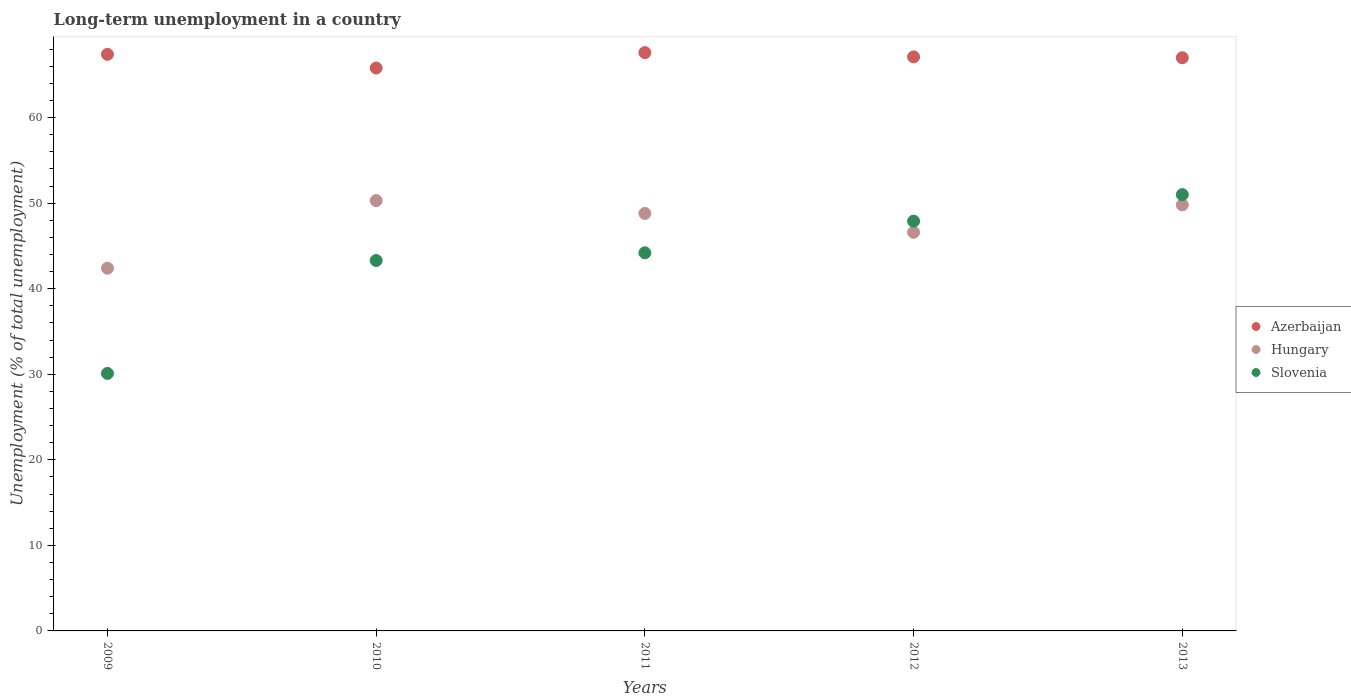How many different coloured dotlines are there?
Offer a very short reply. 3. Is the number of dotlines equal to the number of legend labels?
Give a very brief answer. Yes. What is the percentage of long-term unemployed population in Azerbaijan in 2010?
Your answer should be compact. 65.8. Across all years, what is the maximum percentage of long-term unemployed population in Slovenia?
Provide a succinct answer. 51. Across all years, what is the minimum percentage of long-term unemployed population in Hungary?
Your answer should be very brief. 42.4. In which year was the percentage of long-term unemployed population in Slovenia maximum?
Make the answer very short. 2013. What is the total percentage of long-term unemployed population in Hungary in the graph?
Your answer should be compact. 237.9. What is the difference between the percentage of long-term unemployed population in Hungary in 2009 and that in 2013?
Keep it short and to the point. -7.4. What is the difference between the percentage of long-term unemployed population in Hungary in 2011 and the percentage of long-term unemployed population in Slovenia in 2012?
Make the answer very short. 0.9. What is the average percentage of long-term unemployed population in Slovenia per year?
Give a very brief answer. 43.3. In the year 2009, what is the difference between the percentage of long-term unemployed population in Hungary and percentage of long-term unemployed population in Slovenia?
Give a very brief answer. 12.3. What is the ratio of the percentage of long-term unemployed population in Hungary in 2009 to that in 2011?
Provide a succinct answer. 0.87. What is the difference between the highest and the second highest percentage of long-term unemployed population in Azerbaijan?
Keep it short and to the point. 0.2. What is the difference between the highest and the lowest percentage of long-term unemployed population in Hungary?
Provide a succinct answer. 7.9. Is the sum of the percentage of long-term unemployed population in Slovenia in 2011 and 2013 greater than the maximum percentage of long-term unemployed population in Azerbaijan across all years?
Your answer should be very brief. Yes. Is it the case that in every year, the sum of the percentage of long-term unemployed population in Slovenia and percentage of long-term unemployed population in Hungary  is greater than the percentage of long-term unemployed population in Azerbaijan?
Keep it short and to the point. Yes. Is the percentage of long-term unemployed population in Azerbaijan strictly less than the percentage of long-term unemployed population in Hungary over the years?
Ensure brevity in your answer.  No. How many years are there in the graph?
Make the answer very short. 5. What is the difference between two consecutive major ticks on the Y-axis?
Ensure brevity in your answer.  10. Does the graph contain grids?
Provide a short and direct response. No. Where does the legend appear in the graph?
Ensure brevity in your answer.  Center right. How many legend labels are there?
Provide a short and direct response. 3. What is the title of the graph?
Make the answer very short. Long-term unemployment in a country. Does "Caribbean small states" appear as one of the legend labels in the graph?
Offer a terse response. No. What is the label or title of the X-axis?
Provide a succinct answer. Years. What is the label or title of the Y-axis?
Keep it short and to the point. Unemployment (% of total unemployment). What is the Unemployment (% of total unemployment) of Azerbaijan in 2009?
Give a very brief answer. 67.4. What is the Unemployment (% of total unemployment) in Hungary in 2009?
Your response must be concise. 42.4. What is the Unemployment (% of total unemployment) of Slovenia in 2009?
Provide a succinct answer. 30.1. What is the Unemployment (% of total unemployment) of Azerbaijan in 2010?
Ensure brevity in your answer.  65.8. What is the Unemployment (% of total unemployment) in Hungary in 2010?
Ensure brevity in your answer.  50.3. What is the Unemployment (% of total unemployment) in Slovenia in 2010?
Ensure brevity in your answer.  43.3. What is the Unemployment (% of total unemployment) in Azerbaijan in 2011?
Offer a very short reply. 67.6. What is the Unemployment (% of total unemployment) of Hungary in 2011?
Provide a succinct answer. 48.8. What is the Unemployment (% of total unemployment) of Slovenia in 2011?
Provide a short and direct response. 44.2. What is the Unemployment (% of total unemployment) in Azerbaijan in 2012?
Ensure brevity in your answer.  67.1. What is the Unemployment (% of total unemployment) of Hungary in 2012?
Offer a very short reply. 46.6. What is the Unemployment (% of total unemployment) in Slovenia in 2012?
Ensure brevity in your answer.  47.9. What is the Unemployment (% of total unemployment) in Azerbaijan in 2013?
Your answer should be very brief. 67. What is the Unemployment (% of total unemployment) in Hungary in 2013?
Keep it short and to the point. 49.8. Across all years, what is the maximum Unemployment (% of total unemployment) in Azerbaijan?
Your answer should be compact. 67.6. Across all years, what is the maximum Unemployment (% of total unemployment) of Hungary?
Your answer should be very brief. 50.3. Across all years, what is the minimum Unemployment (% of total unemployment) of Azerbaijan?
Provide a succinct answer. 65.8. Across all years, what is the minimum Unemployment (% of total unemployment) of Hungary?
Make the answer very short. 42.4. Across all years, what is the minimum Unemployment (% of total unemployment) in Slovenia?
Your answer should be compact. 30.1. What is the total Unemployment (% of total unemployment) in Azerbaijan in the graph?
Your answer should be compact. 334.9. What is the total Unemployment (% of total unemployment) of Hungary in the graph?
Provide a succinct answer. 237.9. What is the total Unemployment (% of total unemployment) in Slovenia in the graph?
Provide a short and direct response. 216.5. What is the difference between the Unemployment (% of total unemployment) in Hungary in 2009 and that in 2010?
Provide a short and direct response. -7.9. What is the difference between the Unemployment (% of total unemployment) in Slovenia in 2009 and that in 2011?
Offer a very short reply. -14.1. What is the difference between the Unemployment (% of total unemployment) of Slovenia in 2009 and that in 2012?
Give a very brief answer. -17.8. What is the difference between the Unemployment (% of total unemployment) of Azerbaijan in 2009 and that in 2013?
Your response must be concise. 0.4. What is the difference between the Unemployment (% of total unemployment) of Hungary in 2009 and that in 2013?
Provide a short and direct response. -7.4. What is the difference between the Unemployment (% of total unemployment) of Slovenia in 2009 and that in 2013?
Your answer should be very brief. -20.9. What is the difference between the Unemployment (% of total unemployment) in Azerbaijan in 2010 and that in 2011?
Provide a succinct answer. -1.8. What is the difference between the Unemployment (% of total unemployment) of Slovenia in 2010 and that in 2011?
Give a very brief answer. -0.9. What is the difference between the Unemployment (% of total unemployment) of Azerbaijan in 2010 and that in 2012?
Make the answer very short. -1.3. What is the difference between the Unemployment (% of total unemployment) in Hungary in 2010 and that in 2012?
Ensure brevity in your answer.  3.7. What is the difference between the Unemployment (% of total unemployment) in Hungary in 2010 and that in 2013?
Offer a terse response. 0.5. What is the difference between the Unemployment (% of total unemployment) of Azerbaijan in 2011 and that in 2012?
Make the answer very short. 0.5. What is the difference between the Unemployment (% of total unemployment) in Slovenia in 2011 and that in 2012?
Provide a succinct answer. -3.7. What is the difference between the Unemployment (% of total unemployment) in Azerbaijan in 2011 and that in 2013?
Your answer should be compact. 0.6. What is the difference between the Unemployment (% of total unemployment) of Azerbaijan in 2012 and that in 2013?
Your answer should be very brief. 0.1. What is the difference between the Unemployment (% of total unemployment) of Slovenia in 2012 and that in 2013?
Your answer should be compact. -3.1. What is the difference between the Unemployment (% of total unemployment) of Azerbaijan in 2009 and the Unemployment (% of total unemployment) of Hungary in 2010?
Offer a very short reply. 17.1. What is the difference between the Unemployment (% of total unemployment) in Azerbaijan in 2009 and the Unemployment (% of total unemployment) in Slovenia in 2010?
Make the answer very short. 24.1. What is the difference between the Unemployment (% of total unemployment) of Hungary in 2009 and the Unemployment (% of total unemployment) of Slovenia in 2010?
Your answer should be very brief. -0.9. What is the difference between the Unemployment (% of total unemployment) in Azerbaijan in 2009 and the Unemployment (% of total unemployment) in Slovenia in 2011?
Provide a succinct answer. 23.2. What is the difference between the Unemployment (% of total unemployment) in Azerbaijan in 2009 and the Unemployment (% of total unemployment) in Hungary in 2012?
Your answer should be very brief. 20.8. What is the difference between the Unemployment (% of total unemployment) in Azerbaijan in 2009 and the Unemployment (% of total unemployment) in Slovenia in 2012?
Give a very brief answer. 19.5. What is the difference between the Unemployment (% of total unemployment) of Hungary in 2009 and the Unemployment (% of total unemployment) of Slovenia in 2012?
Offer a very short reply. -5.5. What is the difference between the Unemployment (% of total unemployment) in Azerbaijan in 2010 and the Unemployment (% of total unemployment) in Slovenia in 2011?
Keep it short and to the point. 21.6. What is the difference between the Unemployment (% of total unemployment) of Azerbaijan in 2010 and the Unemployment (% of total unemployment) of Slovenia in 2012?
Provide a short and direct response. 17.9. What is the difference between the Unemployment (% of total unemployment) in Hungary in 2010 and the Unemployment (% of total unemployment) in Slovenia in 2012?
Offer a very short reply. 2.4. What is the difference between the Unemployment (% of total unemployment) of Azerbaijan in 2011 and the Unemployment (% of total unemployment) of Slovenia in 2012?
Your response must be concise. 19.7. What is the difference between the Unemployment (% of total unemployment) in Hungary in 2011 and the Unemployment (% of total unemployment) in Slovenia in 2012?
Make the answer very short. 0.9. What is the difference between the Unemployment (% of total unemployment) in Azerbaijan in 2011 and the Unemployment (% of total unemployment) in Hungary in 2013?
Offer a terse response. 17.8. What is the difference between the Unemployment (% of total unemployment) in Azerbaijan in 2012 and the Unemployment (% of total unemployment) in Hungary in 2013?
Give a very brief answer. 17.3. What is the difference between the Unemployment (% of total unemployment) in Hungary in 2012 and the Unemployment (% of total unemployment) in Slovenia in 2013?
Your answer should be compact. -4.4. What is the average Unemployment (% of total unemployment) in Azerbaijan per year?
Give a very brief answer. 66.98. What is the average Unemployment (% of total unemployment) of Hungary per year?
Your answer should be compact. 47.58. What is the average Unemployment (% of total unemployment) of Slovenia per year?
Provide a short and direct response. 43.3. In the year 2009, what is the difference between the Unemployment (% of total unemployment) in Azerbaijan and Unemployment (% of total unemployment) in Hungary?
Provide a short and direct response. 25. In the year 2009, what is the difference between the Unemployment (% of total unemployment) in Azerbaijan and Unemployment (% of total unemployment) in Slovenia?
Ensure brevity in your answer.  37.3. In the year 2009, what is the difference between the Unemployment (% of total unemployment) of Hungary and Unemployment (% of total unemployment) of Slovenia?
Give a very brief answer. 12.3. In the year 2011, what is the difference between the Unemployment (% of total unemployment) of Azerbaijan and Unemployment (% of total unemployment) of Slovenia?
Give a very brief answer. 23.4. In the year 2012, what is the difference between the Unemployment (% of total unemployment) of Azerbaijan and Unemployment (% of total unemployment) of Slovenia?
Your response must be concise. 19.2. In the year 2013, what is the difference between the Unemployment (% of total unemployment) of Azerbaijan and Unemployment (% of total unemployment) of Hungary?
Give a very brief answer. 17.2. In the year 2013, what is the difference between the Unemployment (% of total unemployment) in Azerbaijan and Unemployment (% of total unemployment) in Slovenia?
Your answer should be compact. 16. What is the ratio of the Unemployment (% of total unemployment) in Azerbaijan in 2009 to that in 2010?
Give a very brief answer. 1.02. What is the ratio of the Unemployment (% of total unemployment) in Hungary in 2009 to that in 2010?
Provide a short and direct response. 0.84. What is the ratio of the Unemployment (% of total unemployment) in Slovenia in 2009 to that in 2010?
Ensure brevity in your answer.  0.7. What is the ratio of the Unemployment (% of total unemployment) in Hungary in 2009 to that in 2011?
Make the answer very short. 0.87. What is the ratio of the Unemployment (% of total unemployment) of Slovenia in 2009 to that in 2011?
Keep it short and to the point. 0.68. What is the ratio of the Unemployment (% of total unemployment) of Azerbaijan in 2009 to that in 2012?
Offer a very short reply. 1. What is the ratio of the Unemployment (% of total unemployment) in Hungary in 2009 to that in 2012?
Your answer should be very brief. 0.91. What is the ratio of the Unemployment (% of total unemployment) of Slovenia in 2009 to that in 2012?
Your response must be concise. 0.63. What is the ratio of the Unemployment (% of total unemployment) in Hungary in 2009 to that in 2013?
Your response must be concise. 0.85. What is the ratio of the Unemployment (% of total unemployment) of Slovenia in 2009 to that in 2013?
Offer a terse response. 0.59. What is the ratio of the Unemployment (% of total unemployment) of Azerbaijan in 2010 to that in 2011?
Your answer should be compact. 0.97. What is the ratio of the Unemployment (% of total unemployment) of Hungary in 2010 to that in 2011?
Your answer should be very brief. 1.03. What is the ratio of the Unemployment (% of total unemployment) in Slovenia in 2010 to that in 2011?
Provide a succinct answer. 0.98. What is the ratio of the Unemployment (% of total unemployment) of Azerbaijan in 2010 to that in 2012?
Make the answer very short. 0.98. What is the ratio of the Unemployment (% of total unemployment) in Hungary in 2010 to that in 2012?
Your answer should be compact. 1.08. What is the ratio of the Unemployment (% of total unemployment) of Slovenia in 2010 to that in 2012?
Make the answer very short. 0.9. What is the ratio of the Unemployment (% of total unemployment) of Azerbaijan in 2010 to that in 2013?
Offer a terse response. 0.98. What is the ratio of the Unemployment (% of total unemployment) of Hungary in 2010 to that in 2013?
Provide a short and direct response. 1.01. What is the ratio of the Unemployment (% of total unemployment) of Slovenia in 2010 to that in 2013?
Ensure brevity in your answer.  0.85. What is the ratio of the Unemployment (% of total unemployment) in Azerbaijan in 2011 to that in 2012?
Your answer should be very brief. 1.01. What is the ratio of the Unemployment (% of total unemployment) in Hungary in 2011 to that in 2012?
Your answer should be very brief. 1.05. What is the ratio of the Unemployment (% of total unemployment) of Slovenia in 2011 to that in 2012?
Offer a very short reply. 0.92. What is the ratio of the Unemployment (% of total unemployment) of Hungary in 2011 to that in 2013?
Give a very brief answer. 0.98. What is the ratio of the Unemployment (% of total unemployment) of Slovenia in 2011 to that in 2013?
Provide a short and direct response. 0.87. What is the ratio of the Unemployment (% of total unemployment) in Azerbaijan in 2012 to that in 2013?
Offer a terse response. 1. What is the ratio of the Unemployment (% of total unemployment) in Hungary in 2012 to that in 2013?
Provide a succinct answer. 0.94. What is the ratio of the Unemployment (% of total unemployment) in Slovenia in 2012 to that in 2013?
Your answer should be compact. 0.94. What is the difference between the highest and the second highest Unemployment (% of total unemployment) in Hungary?
Your answer should be very brief. 0.5. What is the difference between the highest and the second highest Unemployment (% of total unemployment) in Slovenia?
Your answer should be compact. 3.1. What is the difference between the highest and the lowest Unemployment (% of total unemployment) of Hungary?
Provide a succinct answer. 7.9. What is the difference between the highest and the lowest Unemployment (% of total unemployment) of Slovenia?
Offer a terse response. 20.9. 